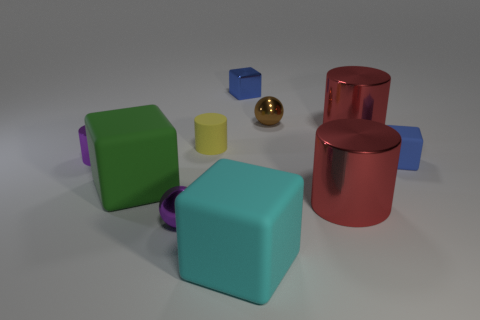Subtract all tiny purple metallic cylinders. How many cylinders are left? 3 Subtract all purple cylinders. How many cylinders are left? 3 Subtract 2 cylinders. How many cylinders are left? 2 Subtract all blue spheres. How many cyan cubes are left? 1 Subtract all cylinders. How many objects are left? 6 Subtract all purple cylinders. Subtract all brown cubes. How many cylinders are left? 3 Add 7 big red shiny objects. How many big red shiny objects exist? 9 Subtract 2 red cylinders. How many objects are left? 8 Subtract all small gray rubber blocks. Subtract all big matte cubes. How many objects are left? 8 Add 5 large green objects. How many large green objects are left? 6 